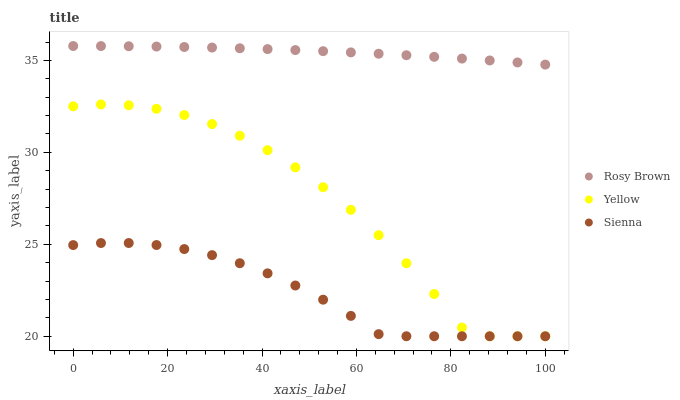Does Sienna have the minimum area under the curve?
Answer yes or no. Yes. Does Rosy Brown have the maximum area under the curve?
Answer yes or no. Yes. Does Yellow have the minimum area under the curve?
Answer yes or no. No. Does Yellow have the maximum area under the curve?
Answer yes or no. No. Is Rosy Brown the smoothest?
Answer yes or no. Yes. Is Yellow the roughest?
Answer yes or no. Yes. Is Yellow the smoothest?
Answer yes or no. No. Is Rosy Brown the roughest?
Answer yes or no. No. Does Sienna have the lowest value?
Answer yes or no. Yes. Does Rosy Brown have the lowest value?
Answer yes or no. No. Does Rosy Brown have the highest value?
Answer yes or no. Yes. Does Yellow have the highest value?
Answer yes or no. No. Is Sienna less than Rosy Brown?
Answer yes or no. Yes. Is Rosy Brown greater than Yellow?
Answer yes or no. Yes. Does Yellow intersect Sienna?
Answer yes or no. Yes. Is Yellow less than Sienna?
Answer yes or no. No. Is Yellow greater than Sienna?
Answer yes or no. No. Does Sienna intersect Rosy Brown?
Answer yes or no. No. 